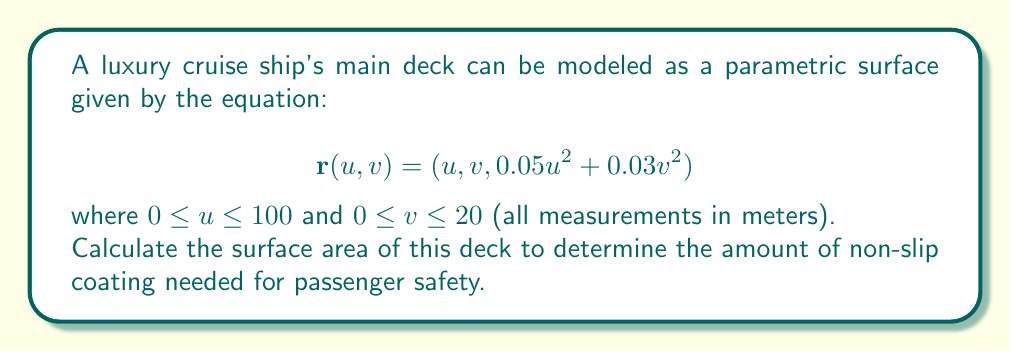Can you solve this math problem? To compute the surface area of a parametric surface, we use the formula:

$$A = \iint_D \left|\frac{\partial \mathbf{r}}{\partial u} \times \frac{\partial \mathbf{r}}{\partial v}\right| du dv$$

Step 1: Calculate the partial derivatives
$$\frac{\partial \mathbf{r}}{\partial u} = (1, 0, 0.1u)$$
$$\frac{\partial \mathbf{r}}{\partial v} = (0, 1, 0.06v)$$

Step 2: Compute the cross product
$$\frac{\partial \mathbf{r}}{\partial u} \times \frac{\partial \mathbf{r}}{\partial v} = (0.1u, 0.06v, 1)$$

Step 3: Calculate the magnitude of the cross product
$$\left|\frac{\partial \mathbf{r}}{\partial u} \times \frac{\partial \mathbf{r}}{\partial v}\right| = \sqrt{(0.1u)^2 + (0.06v)^2 + 1^2}$$

Step 4: Set up the double integral
$$A = \int_0^{20} \int_0^{100} \sqrt{0.01u^2 + 0.0036v^2 + 1} \, du \, dv$$

Step 5: Evaluate the integral
This integral is complex and doesn't have a simple closed-form solution. We can approximate it numerically using a computer algebra system or numerical integration methods.

Using numerical integration, we get:
$$A \approx 2006.67 \text{ m}^2$$
Answer: $2006.67 \text{ m}^2$ 